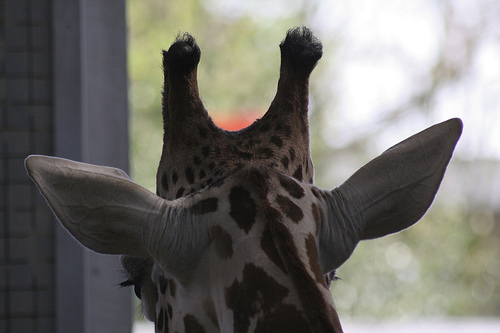<image>
Is the giraffe in the building? Yes. The giraffe is contained within or inside the building, showing a containment relationship. 